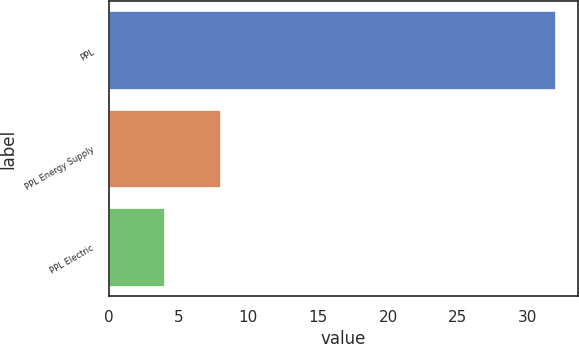Convert chart to OTSL. <chart><loc_0><loc_0><loc_500><loc_500><bar_chart><fcel>PPL<fcel>PPL Energy Supply<fcel>PPL Electric<nl><fcel>32<fcel>8<fcel>4<nl></chart> 